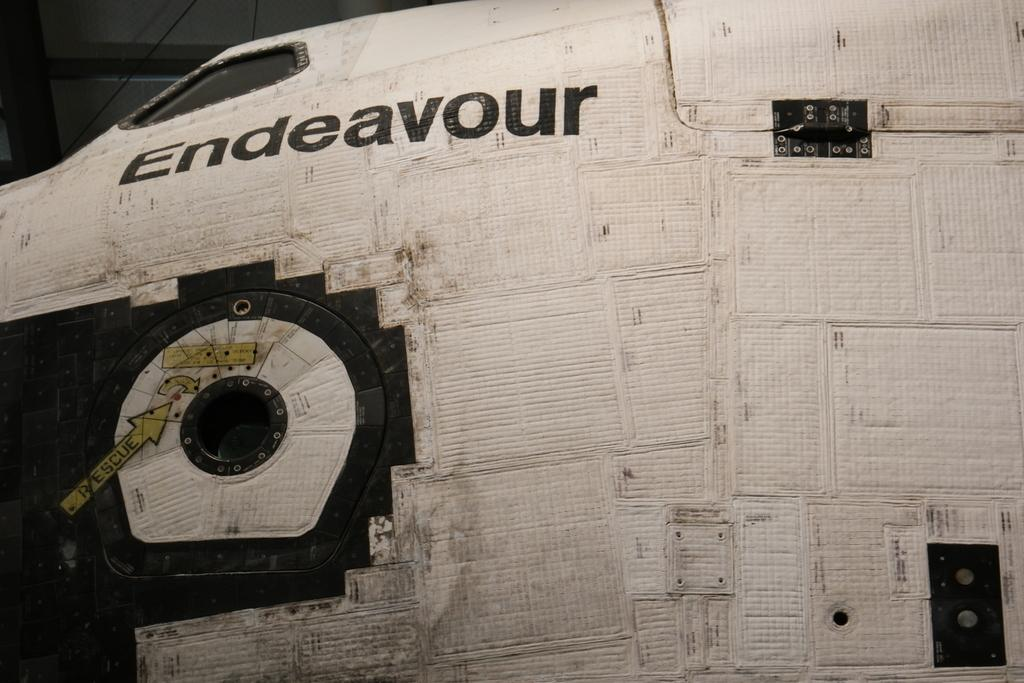<image>
Summarize the visual content of the image. Endeavour is printed in black on a white surface. 